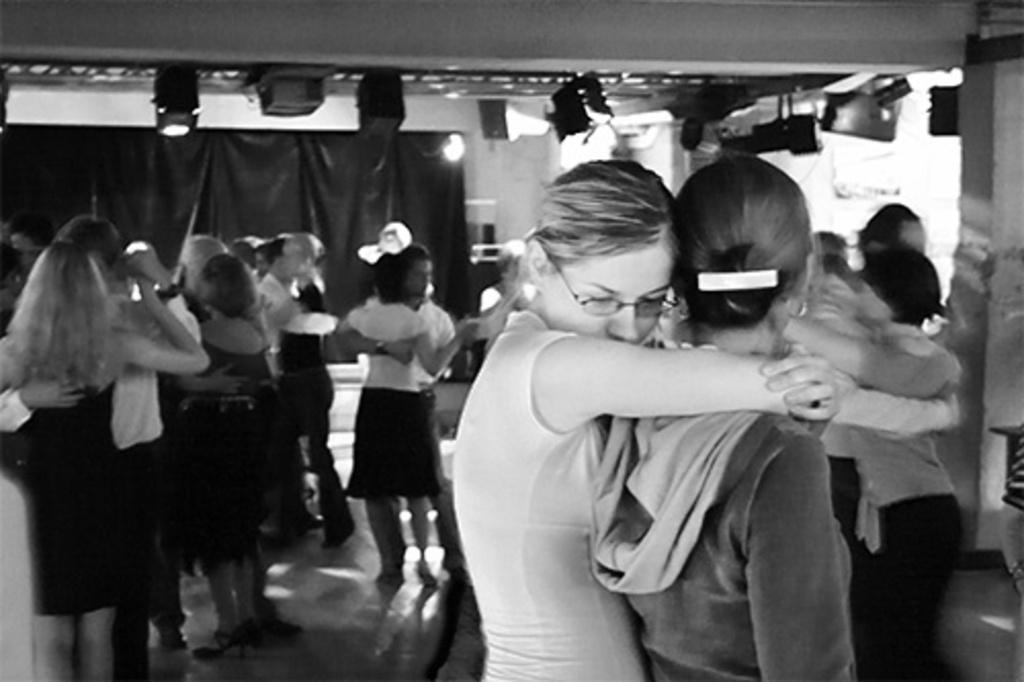Who or what can be seen in the image? There are people in the image. What type of material is visible in the image? There is cloth visible in the image. What can be used for illumination in the image? There are lights in the image. What color is the wall in the image? There is a white color wall in the image. What type of cake is being served at the birthday party in the image? There is no cake or birthday party present in the image. Where is the mailbox located in the image? There is no mailbox present in the image. 